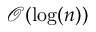<formula> <loc_0><loc_0><loc_500><loc_500>{ \mathcal { O } } ( \log ( n ) )</formula> 